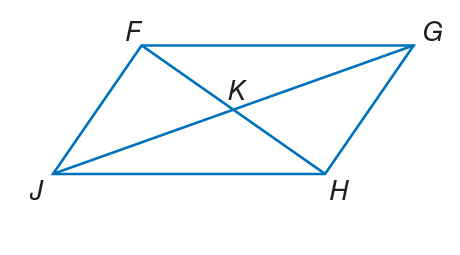Question: If F K = 3 x - 1, K G = 4 y + 3, J K = 6 y - 2, and K H = 2 x + 3, find x so that the quadrilateral is a parallelogram.
Choices:
A. 4
B. 5
C. 10
D. 12
Answer with the letter. Answer: A Question: If F K = 3 x - 1, K G = 4 y + 3, J K = 6 y - 2, and K H = 2 x + 3, find y so that the quadrilateral is a parallelogram.
Choices:
A. 1
B. 2.5
C. 3
D. 5
Answer with the letter. Answer: B 